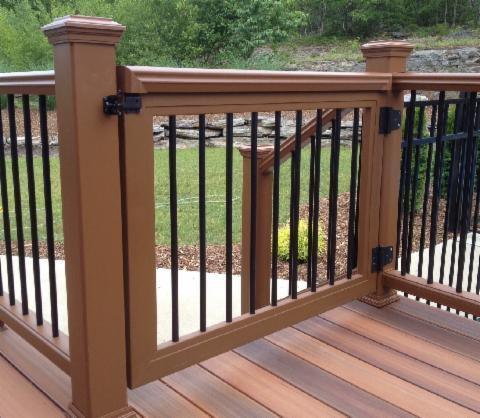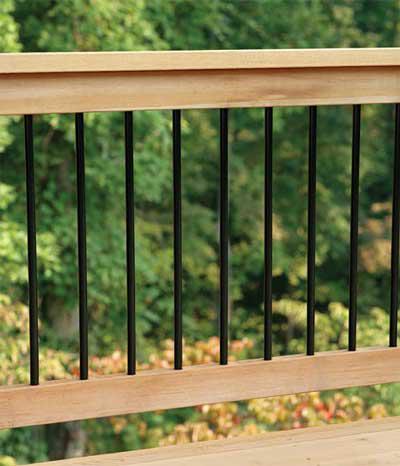The first image is the image on the left, the second image is the image on the right. Considering the images on both sides, is "There are railings made of wood in each image" valid? Answer yes or no. Yes. The first image is the image on the left, the second image is the image on the right. Assess this claim about the two images: "One image shows an all-black metal gate with hinges on the left and the latch on the right.". Correct or not? Answer yes or no. No. 